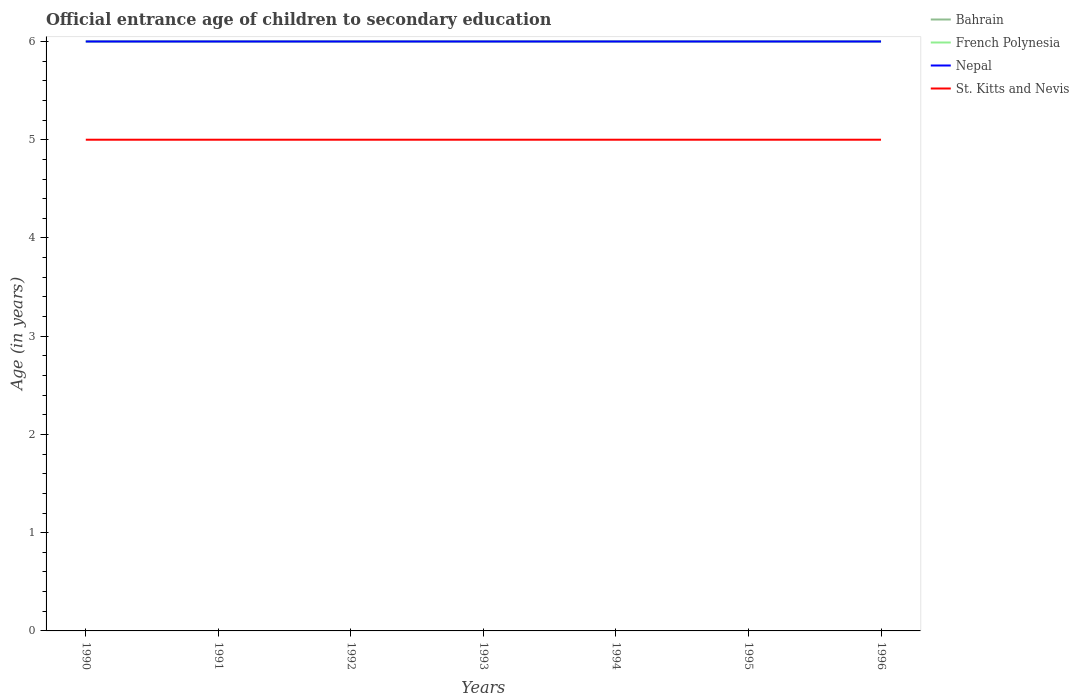How many different coloured lines are there?
Provide a succinct answer. 4. Is the number of lines equal to the number of legend labels?
Make the answer very short. Yes. Across all years, what is the maximum secondary school starting age of children in St. Kitts and Nevis?
Keep it short and to the point. 5. What is the total secondary school starting age of children in St. Kitts and Nevis in the graph?
Ensure brevity in your answer.  0. Is the secondary school starting age of children in St. Kitts and Nevis strictly greater than the secondary school starting age of children in French Polynesia over the years?
Provide a succinct answer. Yes. How many years are there in the graph?
Offer a terse response. 7. Are the values on the major ticks of Y-axis written in scientific E-notation?
Provide a succinct answer. No. Does the graph contain any zero values?
Provide a short and direct response. No. Does the graph contain grids?
Your response must be concise. No. How many legend labels are there?
Offer a very short reply. 4. What is the title of the graph?
Provide a short and direct response. Official entrance age of children to secondary education. Does "Norway" appear as one of the legend labels in the graph?
Keep it short and to the point. No. What is the label or title of the Y-axis?
Offer a very short reply. Age (in years). What is the Age (in years) of Bahrain in 1990?
Ensure brevity in your answer.  6. What is the Age (in years) of Nepal in 1990?
Provide a succinct answer. 6. What is the Age (in years) in St. Kitts and Nevis in 1990?
Provide a succinct answer. 5. What is the Age (in years) of St. Kitts and Nevis in 1992?
Make the answer very short. 5. What is the Age (in years) of Bahrain in 1993?
Provide a short and direct response. 6. What is the Age (in years) in Bahrain in 1994?
Your response must be concise. 6. What is the Age (in years) of French Polynesia in 1994?
Offer a terse response. 6. What is the Age (in years) in Nepal in 1994?
Make the answer very short. 6. What is the Age (in years) in St. Kitts and Nevis in 1994?
Your answer should be very brief. 5. What is the Age (in years) of Bahrain in 1995?
Your response must be concise. 6. What is the Age (in years) in French Polynesia in 1995?
Give a very brief answer. 6. What is the Age (in years) of St. Kitts and Nevis in 1995?
Your answer should be compact. 5. What is the Age (in years) in Bahrain in 1996?
Offer a terse response. 6. What is the Age (in years) in Nepal in 1996?
Your response must be concise. 6. Across all years, what is the maximum Age (in years) of Bahrain?
Give a very brief answer. 6. Across all years, what is the maximum Age (in years) of French Polynesia?
Keep it short and to the point. 6. Across all years, what is the maximum Age (in years) of St. Kitts and Nevis?
Ensure brevity in your answer.  5. Across all years, what is the minimum Age (in years) of French Polynesia?
Offer a very short reply. 6. What is the total Age (in years) in Nepal in the graph?
Offer a very short reply. 42. What is the difference between the Age (in years) of Bahrain in 1990 and that in 1991?
Give a very brief answer. 0. What is the difference between the Age (in years) of Bahrain in 1990 and that in 1992?
Provide a short and direct response. 0. What is the difference between the Age (in years) in Nepal in 1990 and that in 1992?
Ensure brevity in your answer.  0. What is the difference between the Age (in years) of Bahrain in 1990 and that in 1993?
Provide a succinct answer. 0. What is the difference between the Age (in years) in French Polynesia in 1990 and that in 1993?
Provide a succinct answer. 0. What is the difference between the Age (in years) of Nepal in 1990 and that in 1993?
Offer a very short reply. 0. What is the difference between the Age (in years) in Bahrain in 1990 and that in 1994?
Your response must be concise. 0. What is the difference between the Age (in years) of French Polynesia in 1990 and that in 1994?
Offer a terse response. 0. What is the difference between the Age (in years) in St. Kitts and Nevis in 1990 and that in 1994?
Offer a very short reply. 0. What is the difference between the Age (in years) in St. Kitts and Nevis in 1990 and that in 1995?
Ensure brevity in your answer.  0. What is the difference between the Age (in years) in French Polynesia in 1990 and that in 1996?
Your answer should be compact. 0. What is the difference between the Age (in years) in St. Kitts and Nevis in 1990 and that in 1996?
Provide a short and direct response. 0. What is the difference between the Age (in years) in Bahrain in 1991 and that in 1992?
Your response must be concise. 0. What is the difference between the Age (in years) of Nepal in 1991 and that in 1992?
Your answer should be very brief. 0. What is the difference between the Age (in years) in Bahrain in 1991 and that in 1993?
Give a very brief answer. 0. What is the difference between the Age (in years) in Nepal in 1991 and that in 1993?
Make the answer very short. 0. What is the difference between the Age (in years) in St. Kitts and Nevis in 1991 and that in 1993?
Make the answer very short. 0. What is the difference between the Age (in years) in Bahrain in 1991 and that in 1994?
Ensure brevity in your answer.  0. What is the difference between the Age (in years) of French Polynesia in 1991 and that in 1994?
Provide a succinct answer. 0. What is the difference between the Age (in years) of Bahrain in 1991 and that in 1995?
Your answer should be very brief. 0. What is the difference between the Age (in years) of Nepal in 1991 and that in 1995?
Make the answer very short. 0. What is the difference between the Age (in years) of St. Kitts and Nevis in 1991 and that in 1996?
Ensure brevity in your answer.  0. What is the difference between the Age (in years) in Bahrain in 1992 and that in 1993?
Your answer should be very brief. 0. What is the difference between the Age (in years) of Nepal in 1992 and that in 1994?
Your response must be concise. 0. What is the difference between the Age (in years) in St. Kitts and Nevis in 1992 and that in 1994?
Your answer should be very brief. 0. What is the difference between the Age (in years) of Nepal in 1992 and that in 1995?
Offer a terse response. 0. What is the difference between the Age (in years) of St. Kitts and Nevis in 1992 and that in 1995?
Your response must be concise. 0. What is the difference between the Age (in years) in French Polynesia in 1992 and that in 1996?
Provide a succinct answer. 0. What is the difference between the Age (in years) in Nepal in 1992 and that in 1996?
Your answer should be compact. 0. What is the difference between the Age (in years) in French Polynesia in 1993 and that in 1994?
Your answer should be compact. 0. What is the difference between the Age (in years) of Nepal in 1993 and that in 1994?
Your response must be concise. 0. What is the difference between the Age (in years) of Nepal in 1993 and that in 1995?
Keep it short and to the point. 0. What is the difference between the Age (in years) of St. Kitts and Nevis in 1993 and that in 1995?
Provide a short and direct response. 0. What is the difference between the Age (in years) of French Polynesia in 1993 and that in 1996?
Your answer should be compact. 0. What is the difference between the Age (in years) in St. Kitts and Nevis in 1993 and that in 1996?
Your response must be concise. 0. What is the difference between the Age (in years) of French Polynesia in 1994 and that in 1995?
Your answer should be compact. 0. What is the difference between the Age (in years) of St. Kitts and Nevis in 1994 and that in 1995?
Your answer should be compact. 0. What is the difference between the Age (in years) in Bahrain in 1995 and that in 1996?
Offer a very short reply. 0. What is the difference between the Age (in years) in Bahrain in 1990 and the Age (in years) in Nepal in 1991?
Make the answer very short. 0. What is the difference between the Age (in years) of Bahrain in 1990 and the Age (in years) of St. Kitts and Nevis in 1991?
Provide a succinct answer. 1. What is the difference between the Age (in years) of French Polynesia in 1990 and the Age (in years) of St. Kitts and Nevis in 1991?
Offer a terse response. 1. What is the difference between the Age (in years) in Nepal in 1990 and the Age (in years) in St. Kitts and Nevis in 1991?
Your answer should be compact. 1. What is the difference between the Age (in years) in Bahrain in 1990 and the Age (in years) in St. Kitts and Nevis in 1992?
Make the answer very short. 1. What is the difference between the Age (in years) of French Polynesia in 1990 and the Age (in years) of St. Kitts and Nevis in 1992?
Your answer should be very brief. 1. What is the difference between the Age (in years) of Bahrain in 1990 and the Age (in years) of Nepal in 1993?
Keep it short and to the point. 0. What is the difference between the Age (in years) in French Polynesia in 1990 and the Age (in years) in Nepal in 1993?
Ensure brevity in your answer.  0. What is the difference between the Age (in years) of French Polynesia in 1990 and the Age (in years) of St. Kitts and Nevis in 1993?
Ensure brevity in your answer.  1. What is the difference between the Age (in years) in Bahrain in 1990 and the Age (in years) in Nepal in 1994?
Your response must be concise. 0. What is the difference between the Age (in years) in Bahrain in 1990 and the Age (in years) in St. Kitts and Nevis in 1994?
Your answer should be compact. 1. What is the difference between the Age (in years) in Nepal in 1990 and the Age (in years) in St. Kitts and Nevis in 1994?
Your answer should be compact. 1. What is the difference between the Age (in years) of Bahrain in 1990 and the Age (in years) of St. Kitts and Nevis in 1995?
Offer a very short reply. 1. What is the difference between the Age (in years) in French Polynesia in 1990 and the Age (in years) in Nepal in 1995?
Offer a very short reply. 0. What is the difference between the Age (in years) of French Polynesia in 1990 and the Age (in years) of Nepal in 1996?
Keep it short and to the point. 0. What is the difference between the Age (in years) in Nepal in 1990 and the Age (in years) in St. Kitts and Nevis in 1996?
Give a very brief answer. 1. What is the difference between the Age (in years) in Bahrain in 1991 and the Age (in years) in Nepal in 1992?
Your answer should be compact. 0. What is the difference between the Age (in years) of Bahrain in 1991 and the Age (in years) of St. Kitts and Nevis in 1992?
Make the answer very short. 1. What is the difference between the Age (in years) of French Polynesia in 1991 and the Age (in years) of Nepal in 1992?
Your answer should be very brief. 0. What is the difference between the Age (in years) in French Polynesia in 1991 and the Age (in years) in St. Kitts and Nevis in 1992?
Provide a succinct answer. 1. What is the difference between the Age (in years) in Bahrain in 1991 and the Age (in years) in French Polynesia in 1993?
Offer a very short reply. 0. What is the difference between the Age (in years) in Bahrain in 1991 and the Age (in years) in St. Kitts and Nevis in 1993?
Keep it short and to the point. 1. What is the difference between the Age (in years) in French Polynesia in 1991 and the Age (in years) in Nepal in 1993?
Keep it short and to the point. 0. What is the difference between the Age (in years) of French Polynesia in 1991 and the Age (in years) of St. Kitts and Nevis in 1993?
Provide a succinct answer. 1. What is the difference between the Age (in years) of Nepal in 1991 and the Age (in years) of St. Kitts and Nevis in 1993?
Keep it short and to the point. 1. What is the difference between the Age (in years) in Bahrain in 1991 and the Age (in years) in French Polynesia in 1994?
Offer a very short reply. 0. What is the difference between the Age (in years) in Bahrain in 1991 and the Age (in years) in Nepal in 1994?
Keep it short and to the point. 0. What is the difference between the Age (in years) in Bahrain in 1991 and the Age (in years) in St. Kitts and Nevis in 1994?
Your answer should be very brief. 1. What is the difference between the Age (in years) of French Polynesia in 1991 and the Age (in years) of St. Kitts and Nevis in 1994?
Ensure brevity in your answer.  1. What is the difference between the Age (in years) of French Polynesia in 1991 and the Age (in years) of Nepal in 1995?
Offer a very short reply. 0. What is the difference between the Age (in years) in French Polynesia in 1991 and the Age (in years) in St. Kitts and Nevis in 1995?
Your answer should be very brief. 1. What is the difference between the Age (in years) in Bahrain in 1991 and the Age (in years) in Nepal in 1996?
Your response must be concise. 0. What is the difference between the Age (in years) in Bahrain in 1991 and the Age (in years) in St. Kitts and Nevis in 1996?
Offer a very short reply. 1. What is the difference between the Age (in years) of Nepal in 1991 and the Age (in years) of St. Kitts and Nevis in 1996?
Your response must be concise. 1. What is the difference between the Age (in years) of French Polynesia in 1992 and the Age (in years) of Nepal in 1993?
Your response must be concise. 0. What is the difference between the Age (in years) in Bahrain in 1992 and the Age (in years) in St. Kitts and Nevis in 1994?
Provide a succinct answer. 1. What is the difference between the Age (in years) in French Polynesia in 1992 and the Age (in years) in Nepal in 1994?
Offer a terse response. 0. What is the difference between the Age (in years) in Nepal in 1992 and the Age (in years) in St. Kitts and Nevis in 1994?
Keep it short and to the point. 1. What is the difference between the Age (in years) in Bahrain in 1992 and the Age (in years) in French Polynesia in 1995?
Your answer should be very brief. 0. What is the difference between the Age (in years) of French Polynesia in 1992 and the Age (in years) of Nepal in 1995?
Keep it short and to the point. 0. What is the difference between the Age (in years) of French Polynesia in 1992 and the Age (in years) of St. Kitts and Nevis in 1995?
Your response must be concise. 1. What is the difference between the Age (in years) in French Polynesia in 1992 and the Age (in years) in St. Kitts and Nevis in 1996?
Keep it short and to the point. 1. What is the difference between the Age (in years) in Bahrain in 1993 and the Age (in years) in Nepal in 1994?
Make the answer very short. 0. What is the difference between the Age (in years) in Bahrain in 1993 and the Age (in years) in St. Kitts and Nevis in 1994?
Provide a short and direct response. 1. What is the difference between the Age (in years) in Nepal in 1993 and the Age (in years) in St. Kitts and Nevis in 1994?
Make the answer very short. 1. What is the difference between the Age (in years) in Bahrain in 1993 and the Age (in years) in French Polynesia in 1995?
Keep it short and to the point. 0. What is the difference between the Age (in years) of Bahrain in 1993 and the Age (in years) of St. Kitts and Nevis in 1995?
Keep it short and to the point. 1. What is the difference between the Age (in years) in French Polynesia in 1993 and the Age (in years) in Nepal in 1995?
Your response must be concise. 0. What is the difference between the Age (in years) in French Polynesia in 1993 and the Age (in years) in St. Kitts and Nevis in 1995?
Provide a succinct answer. 1. What is the difference between the Age (in years) in Bahrain in 1993 and the Age (in years) in Nepal in 1996?
Offer a very short reply. 0. What is the difference between the Age (in years) of Bahrain in 1993 and the Age (in years) of St. Kitts and Nevis in 1996?
Keep it short and to the point. 1. What is the difference between the Age (in years) of French Polynesia in 1993 and the Age (in years) of Nepal in 1996?
Provide a succinct answer. 0. What is the difference between the Age (in years) in French Polynesia in 1993 and the Age (in years) in St. Kitts and Nevis in 1996?
Make the answer very short. 1. What is the difference between the Age (in years) of French Polynesia in 1994 and the Age (in years) of Nepal in 1995?
Provide a short and direct response. 0. What is the difference between the Age (in years) in French Polynesia in 1994 and the Age (in years) in St. Kitts and Nevis in 1995?
Provide a succinct answer. 1. What is the difference between the Age (in years) of Bahrain in 1994 and the Age (in years) of French Polynesia in 1996?
Make the answer very short. 0. What is the difference between the Age (in years) of French Polynesia in 1994 and the Age (in years) of Nepal in 1996?
Give a very brief answer. 0. What is the difference between the Age (in years) in Nepal in 1994 and the Age (in years) in St. Kitts and Nevis in 1996?
Your response must be concise. 1. What is the difference between the Age (in years) of Bahrain in 1995 and the Age (in years) of St. Kitts and Nevis in 1996?
Your answer should be very brief. 1. What is the difference between the Age (in years) of French Polynesia in 1995 and the Age (in years) of Nepal in 1996?
Provide a short and direct response. 0. What is the difference between the Age (in years) of French Polynesia in 1995 and the Age (in years) of St. Kitts and Nevis in 1996?
Give a very brief answer. 1. What is the average Age (in years) of Bahrain per year?
Offer a terse response. 6. What is the average Age (in years) in French Polynesia per year?
Provide a succinct answer. 6. What is the average Age (in years) in St. Kitts and Nevis per year?
Keep it short and to the point. 5. In the year 1990, what is the difference between the Age (in years) of Bahrain and Age (in years) of French Polynesia?
Keep it short and to the point. 0. In the year 1990, what is the difference between the Age (in years) in Bahrain and Age (in years) in Nepal?
Make the answer very short. 0. In the year 1990, what is the difference between the Age (in years) in Bahrain and Age (in years) in St. Kitts and Nevis?
Give a very brief answer. 1. In the year 1990, what is the difference between the Age (in years) in French Polynesia and Age (in years) in Nepal?
Make the answer very short. 0. In the year 1991, what is the difference between the Age (in years) in Bahrain and Age (in years) in Nepal?
Your answer should be compact. 0. In the year 1991, what is the difference between the Age (in years) of French Polynesia and Age (in years) of St. Kitts and Nevis?
Make the answer very short. 1. In the year 1992, what is the difference between the Age (in years) in Bahrain and Age (in years) in Nepal?
Keep it short and to the point. 0. In the year 1992, what is the difference between the Age (in years) of French Polynesia and Age (in years) of Nepal?
Your answer should be very brief. 0. In the year 1992, what is the difference between the Age (in years) of French Polynesia and Age (in years) of St. Kitts and Nevis?
Give a very brief answer. 1. In the year 1993, what is the difference between the Age (in years) in Bahrain and Age (in years) in French Polynesia?
Your answer should be compact. 0. In the year 1993, what is the difference between the Age (in years) of Bahrain and Age (in years) of Nepal?
Ensure brevity in your answer.  0. In the year 1993, what is the difference between the Age (in years) of French Polynesia and Age (in years) of Nepal?
Offer a terse response. 0. In the year 1993, what is the difference between the Age (in years) of French Polynesia and Age (in years) of St. Kitts and Nevis?
Your answer should be very brief. 1. In the year 1994, what is the difference between the Age (in years) in Bahrain and Age (in years) in French Polynesia?
Your answer should be compact. 0. In the year 1994, what is the difference between the Age (in years) in Bahrain and Age (in years) in Nepal?
Your answer should be compact. 0. In the year 1994, what is the difference between the Age (in years) in Bahrain and Age (in years) in St. Kitts and Nevis?
Offer a very short reply. 1. In the year 1994, what is the difference between the Age (in years) in French Polynesia and Age (in years) in St. Kitts and Nevis?
Ensure brevity in your answer.  1. In the year 1995, what is the difference between the Age (in years) of Bahrain and Age (in years) of Nepal?
Your answer should be very brief. 0. In the year 1995, what is the difference between the Age (in years) of Bahrain and Age (in years) of St. Kitts and Nevis?
Provide a short and direct response. 1. In the year 1995, what is the difference between the Age (in years) in French Polynesia and Age (in years) in St. Kitts and Nevis?
Your response must be concise. 1. In the year 1995, what is the difference between the Age (in years) in Nepal and Age (in years) in St. Kitts and Nevis?
Provide a succinct answer. 1. In the year 1996, what is the difference between the Age (in years) in Bahrain and Age (in years) in Nepal?
Make the answer very short. 0. In the year 1996, what is the difference between the Age (in years) in French Polynesia and Age (in years) in Nepal?
Offer a very short reply. 0. In the year 1996, what is the difference between the Age (in years) of Nepal and Age (in years) of St. Kitts and Nevis?
Your answer should be compact. 1. What is the ratio of the Age (in years) of Bahrain in 1990 to that in 1991?
Offer a terse response. 1. What is the ratio of the Age (in years) in Bahrain in 1990 to that in 1992?
Provide a short and direct response. 1. What is the ratio of the Age (in years) in French Polynesia in 1990 to that in 1992?
Give a very brief answer. 1. What is the ratio of the Age (in years) of French Polynesia in 1990 to that in 1993?
Your answer should be very brief. 1. What is the ratio of the Age (in years) in Nepal in 1990 to that in 1993?
Your answer should be compact. 1. What is the ratio of the Age (in years) in St. Kitts and Nevis in 1990 to that in 1993?
Provide a short and direct response. 1. What is the ratio of the Age (in years) in Bahrain in 1990 to that in 1994?
Offer a very short reply. 1. What is the ratio of the Age (in years) in Nepal in 1990 to that in 1994?
Give a very brief answer. 1. What is the ratio of the Age (in years) in St. Kitts and Nevis in 1990 to that in 1994?
Offer a very short reply. 1. What is the ratio of the Age (in years) of French Polynesia in 1990 to that in 1996?
Your response must be concise. 1. What is the ratio of the Age (in years) in Nepal in 1990 to that in 1996?
Your answer should be very brief. 1. What is the ratio of the Age (in years) in St. Kitts and Nevis in 1990 to that in 1996?
Your answer should be very brief. 1. What is the ratio of the Age (in years) of Nepal in 1991 to that in 1992?
Offer a terse response. 1. What is the ratio of the Age (in years) of French Polynesia in 1991 to that in 1993?
Provide a succinct answer. 1. What is the ratio of the Age (in years) of St. Kitts and Nevis in 1991 to that in 1993?
Make the answer very short. 1. What is the ratio of the Age (in years) in French Polynesia in 1991 to that in 1994?
Make the answer very short. 1. What is the ratio of the Age (in years) of St. Kitts and Nevis in 1991 to that in 1994?
Make the answer very short. 1. What is the ratio of the Age (in years) in Bahrain in 1991 to that in 1995?
Your response must be concise. 1. What is the ratio of the Age (in years) of St. Kitts and Nevis in 1991 to that in 1995?
Make the answer very short. 1. What is the ratio of the Age (in years) in Bahrain in 1991 to that in 1996?
Make the answer very short. 1. What is the ratio of the Age (in years) of Bahrain in 1992 to that in 1993?
Make the answer very short. 1. What is the ratio of the Age (in years) of Nepal in 1992 to that in 1993?
Make the answer very short. 1. What is the ratio of the Age (in years) in St. Kitts and Nevis in 1992 to that in 1993?
Your answer should be very brief. 1. What is the ratio of the Age (in years) in Bahrain in 1992 to that in 1994?
Provide a succinct answer. 1. What is the ratio of the Age (in years) of French Polynesia in 1992 to that in 1994?
Offer a terse response. 1. What is the ratio of the Age (in years) of Nepal in 1992 to that in 1994?
Provide a short and direct response. 1. What is the ratio of the Age (in years) of French Polynesia in 1992 to that in 1995?
Make the answer very short. 1. What is the ratio of the Age (in years) in Bahrain in 1992 to that in 1996?
Keep it short and to the point. 1. What is the ratio of the Age (in years) of French Polynesia in 1992 to that in 1996?
Ensure brevity in your answer.  1. What is the ratio of the Age (in years) of Nepal in 1992 to that in 1996?
Ensure brevity in your answer.  1. What is the ratio of the Age (in years) of French Polynesia in 1993 to that in 1994?
Make the answer very short. 1. What is the ratio of the Age (in years) of Nepal in 1993 to that in 1994?
Your response must be concise. 1. What is the ratio of the Age (in years) of St. Kitts and Nevis in 1993 to that in 1994?
Offer a very short reply. 1. What is the ratio of the Age (in years) of French Polynesia in 1993 to that in 1995?
Give a very brief answer. 1. What is the ratio of the Age (in years) in French Polynesia in 1993 to that in 1996?
Your response must be concise. 1. What is the ratio of the Age (in years) of St. Kitts and Nevis in 1993 to that in 1996?
Provide a short and direct response. 1. What is the ratio of the Age (in years) of French Polynesia in 1994 to that in 1995?
Offer a terse response. 1. What is the ratio of the Age (in years) of Nepal in 1994 to that in 1995?
Provide a short and direct response. 1. What is the ratio of the Age (in years) of St. Kitts and Nevis in 1994 to that in 1995?
Give a very brief answer. 1. What is the ratio of the Age (in years) in Bahrain in 1994 to that in 1996?
Offer a very short reply. 1. What is the ratio of the Age (in years) in Nepal in 1994 to that in 1996?
Your response must be concise. 1. What is the ratio of the Age (in years) in St. Kitts and Nevis in 1994 to that in 1996?
Your response must be concise. 1. What is the ratio of the Age (in years) of Bahrain in 1995 to that in 1996?
Provide a succinct answer. 1. What is the ratio of the Age (in years) in French Polynesia in 1995 to that in 1996?
Make the answer very short. 1. What is the ratio of the Age (in years) in St. Kitts and Nevis in 1995 to that in 1996?
Provide a short and direct response. 1. What is the difference between the highest and the second highest Age (in years) of Nepal?
Your answer should be compact. 0. What is the difference between the highest and the lowest Age (in years) in Nepal?
Keep it short and to the point. 0. What is the difference between the highest and the lowest Age (in years) of St. Kitts and Nevis?
Offer a very short reply. 0. 